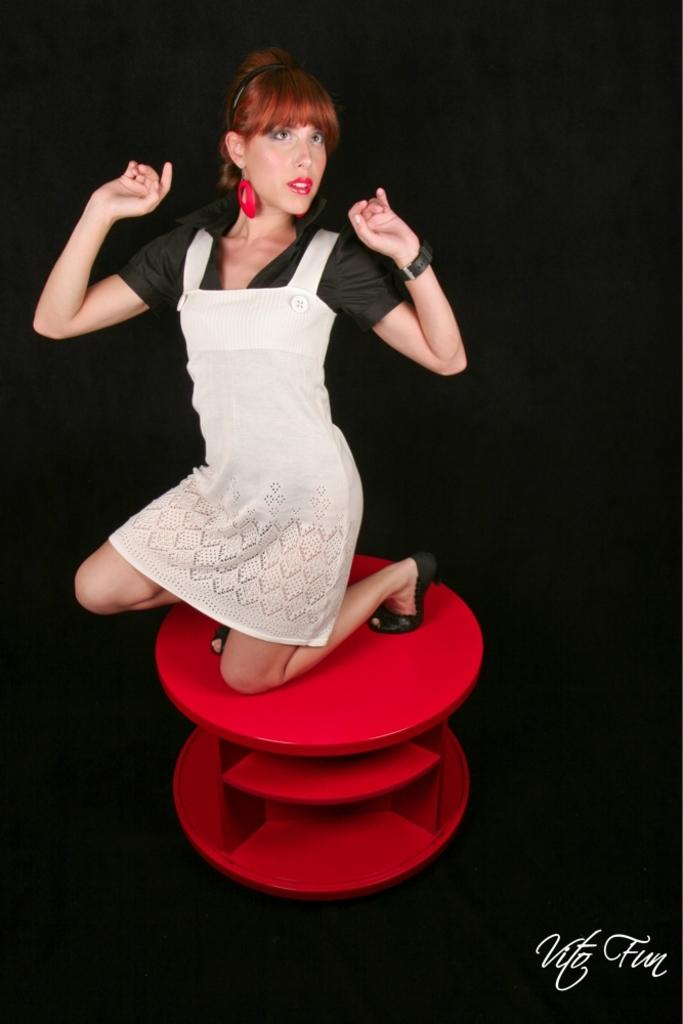What color is the table in the image? The table in the image is red. What is on top of the red table? There is a woman on the red table. What color is the background of the image? The background of the image is black. Is there any text or logo visible in the image? Yes, there is a watermark at the bottom of the image. Are there any plants or plantation visible in the image? No, there are no plants or plantation visible in the image. Can you see a horse in the image? No, there is no horse present in the image. 